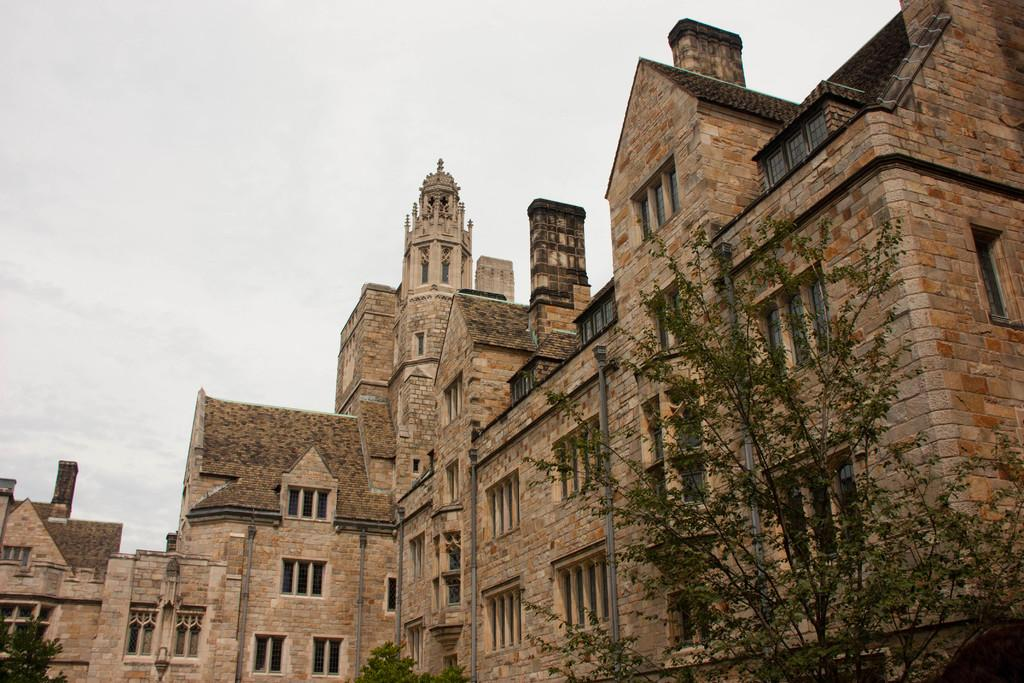What is the main structure in the image? There is a huge building in the image. What feature can be seen on the building? The building has windows. What type of vegetation is near the building? There are plants and a tree near the building. What can be seen in the background of the image? The sky is visible behind the building. What type of vacation is the building taking in the image? The building is not taking a vacation; it is a stationary structure in the image. What authority does the building have in the image? The building does not have any authority in the image; it is simply a large structure. 